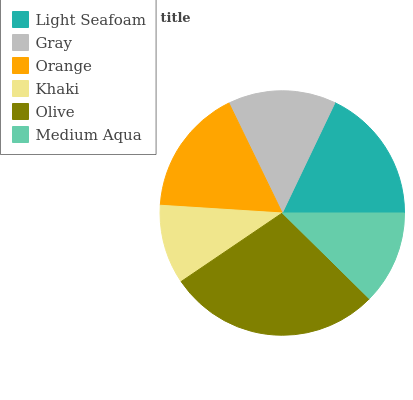Is Khaki the minimum?
Answer yes or no. Yes. Is Olive the maximum?
Answer yes or no. Yes. Is Gray the minimum?
Answer yes or no. No. Is Gray the maximum?
Answer yes or no. No. Is Light Seafoam greater than Gray?
Answer yes or no. Yes. Is Gray less than Light Seafoam?
Answer yes or no. Yes. Is Gray greater than Light Seafoam?
Answer yes or no. No. Is Light Seafoam less than Gray?
Answer yes or no. No. Is Orange the high median?
Answer yes or no. Yes. Is Gray the low median?
Answer yes or no. Yes. Is Olive the high median?
Answer yes or no. No. Is Medium Aqua the low median?
Answer yes or no. No. 